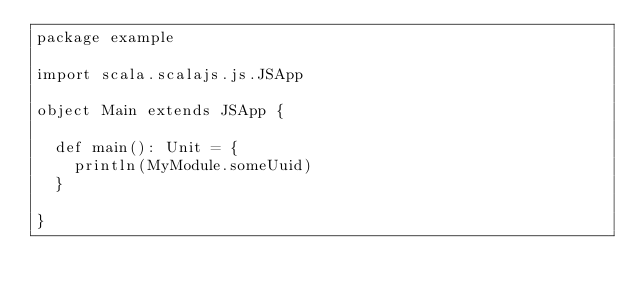Convert code to text. <code><loc_0><loc_0><loc_500><loc_500><_Scala_>package example

import scala.scalajs.js.JSApp

object Main extends JSApp {

  def main(): Unit = {
    println(MyModule.someUuid)
  }

}</code> 